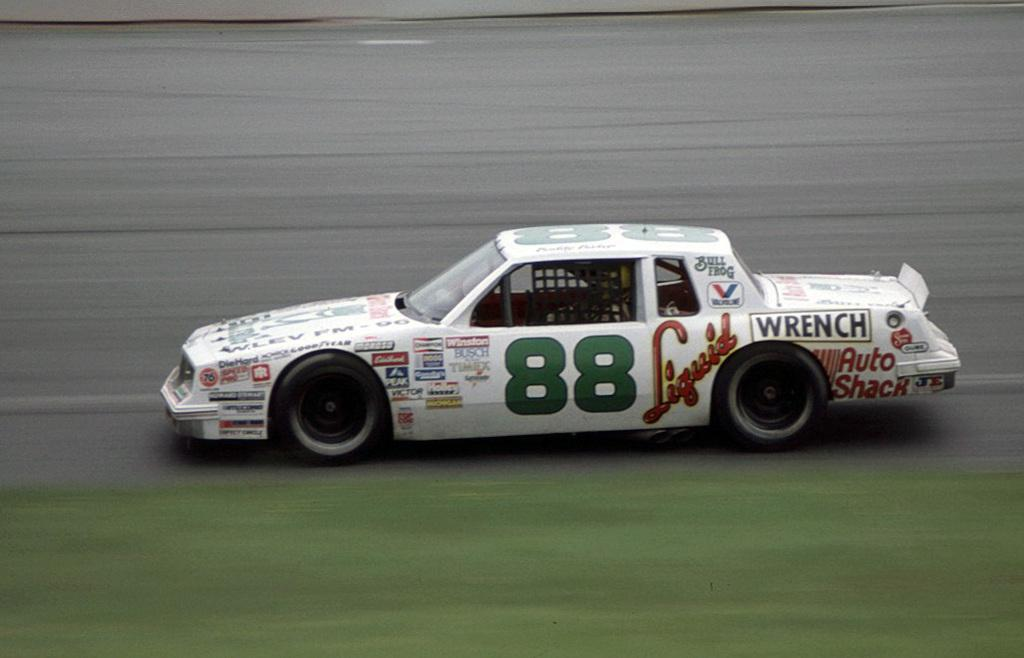What is the main subject in the center of the image? There is a car in the center of the image. What type of terrain is visible at the bottom of the image? There is grass at the bottom of the image. What is the car positioned on in the image? There is a road in the center of the image. What color is the sheet draped over the car in the image? There is no sheet draped over the car in the image. 